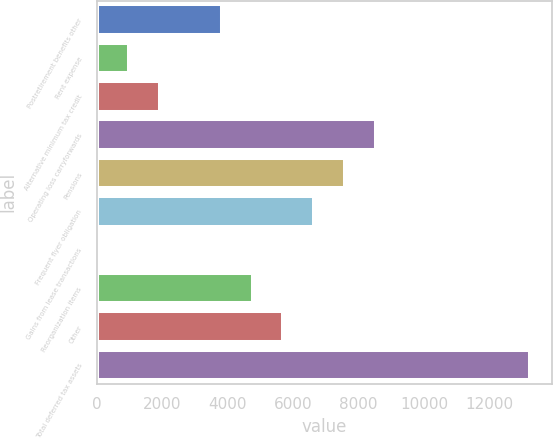<chart> <loc_0><loc_0><loc_500><loc_500><bar_chart><fcel>Postretirement benefits other<fcel>Rent expense<fcel>Alternative minimum tax credit<fcel>Operating loss carryforwards<fcel>Pensions<fcel>Frequent flyer obligation<fcel>Gains from lease transactions<fcel>Reorganization items<fcel>Other<fcel>Total deferred tax assets<nl><fcel>3822.4<fcel>997.6<fcel>1939.2<fcel>8530.4<fcel>7588.8<fcel>6647.2<fcel>56<fcel>4764<fcel>5705.6<fcel>13238.4<nl></chart> 